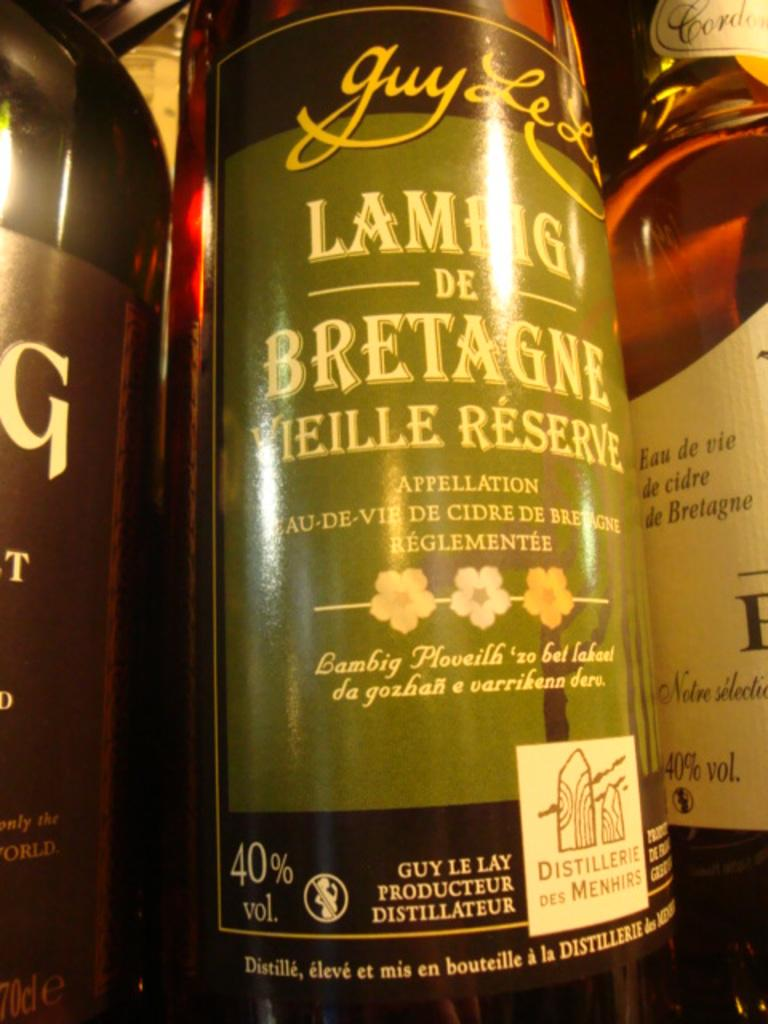Provide a one-sentence caption for the provided image. A bottle with Lambig de Bretagne written on it. 